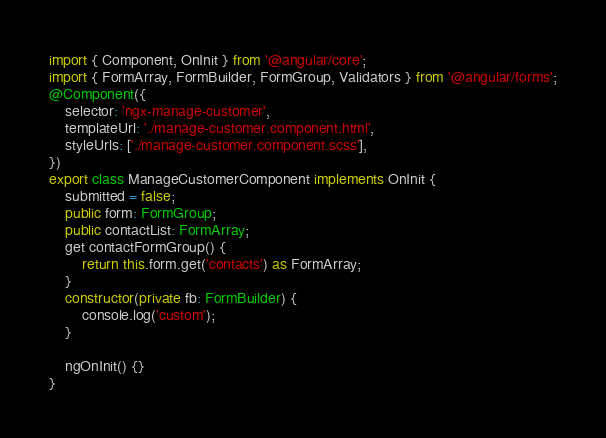<code> <loc_0><loc_0><loc_500><loc_500><_TypeScript_>import { Component, OnInit } from '@angular/core';
import { FormArray, FormBuilder, FormGroup, Validators } from '@angular/forms';
@Component({
    selector: 'ngx-manage-customer',
    templateUrl: './manage-customer.component.html',
    styleUrls: ['./manage-customer.component.scss'],
})
export class ManageCustomerComponent implements OnInit {
    submitted = false;
    public form: FormGroup;
    public contactList: FormArray;
    get contactFormGroup() {
        return this.form.get('contacts') as FormArray;
    }
    constructor(private fb: FormBuilder) {
        console.log('custom');
    }

    ngOnInit() {}
}
</code> 